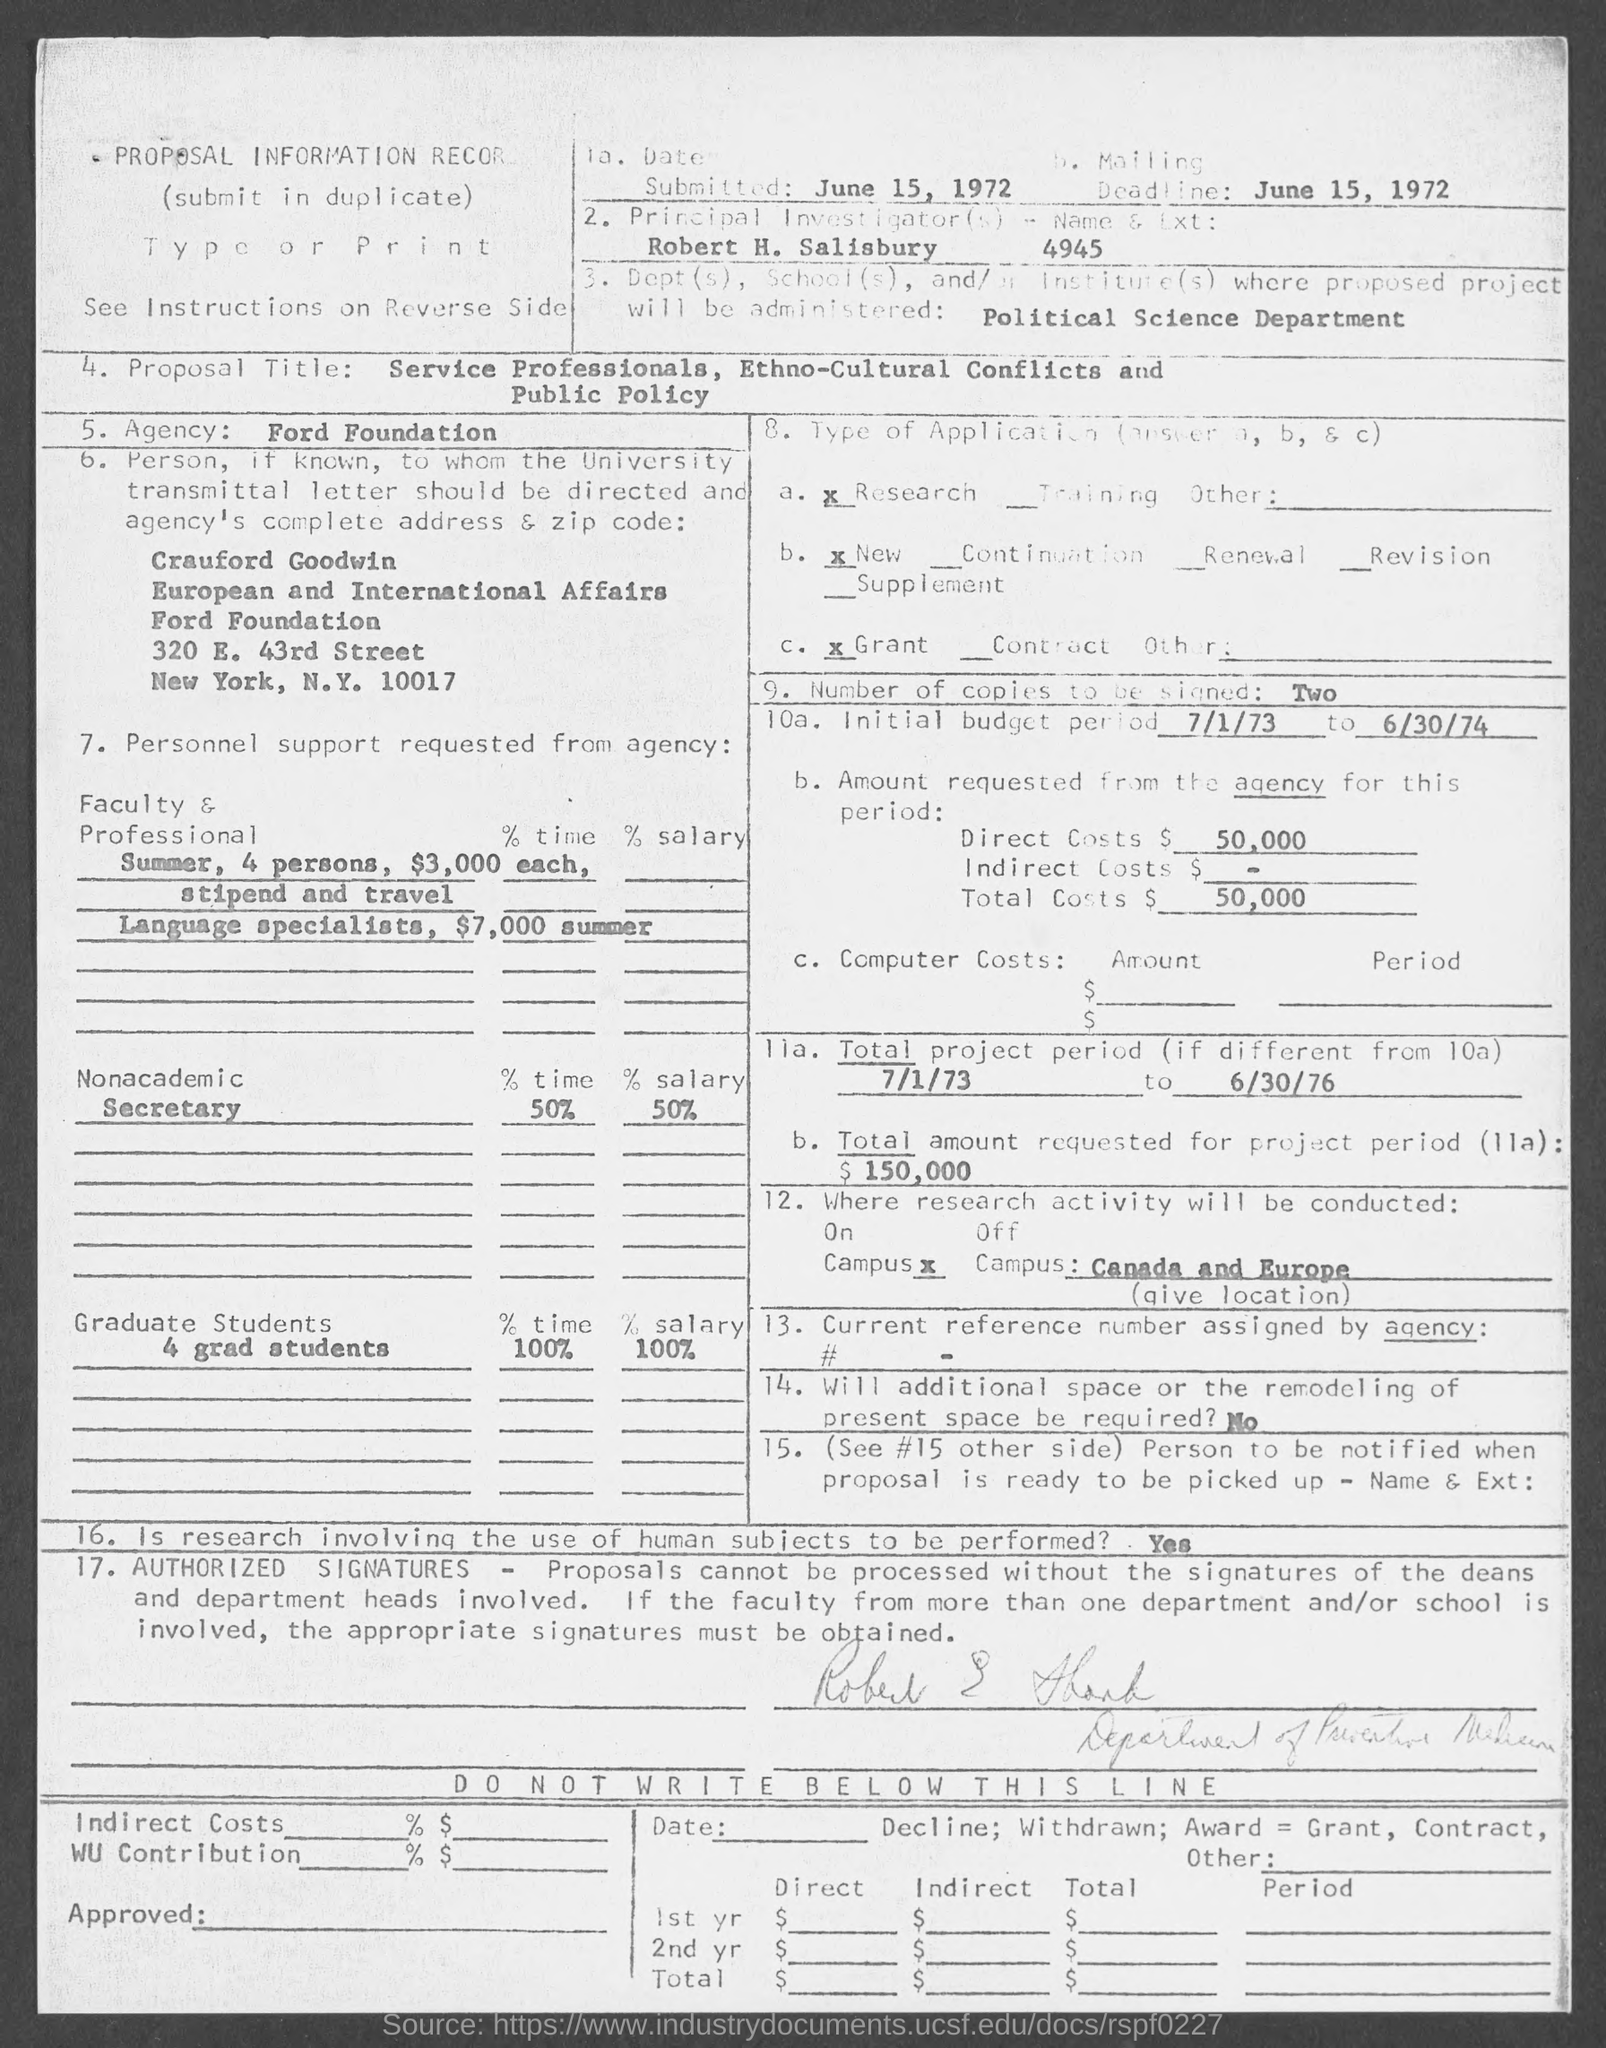How much is the Direct Costs ?
Your response must be concise. 50,000. What is the Initial budget period ?
Your response must be concise. 7/1/73 to 6/30/74. What is the Zip code ?
Your response must be concise. 10017. 